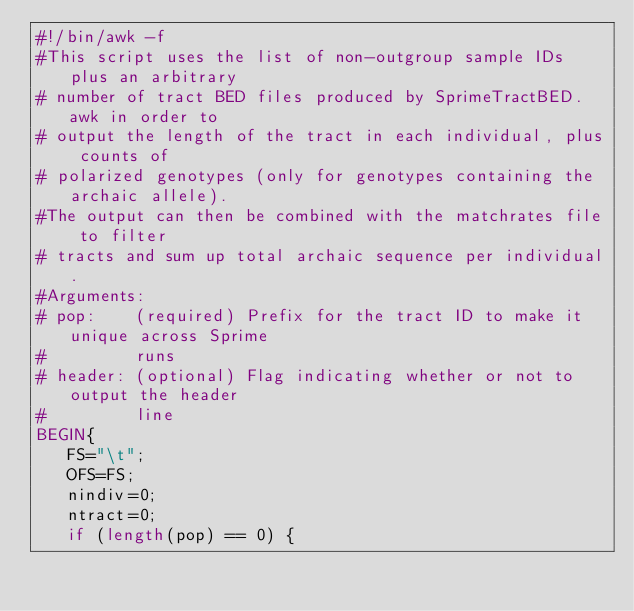<code> <loc_0><loc_0><loc_500><loc_500><_Awk_>#!/bin/awk -f
#This script uses the list of non-outgroup sample IDs plus an arbitrary
# number of tract BED files produced by SprimeTractBED.awk in order to
# output the length of the tract in each individual, plus counts of
# polarized genotypes (only for genotypes containing the archaic allele).
#The output can then be combined with the matchrates file to filter
# tracts and sum up total archaic sequence per individual.
#Arguments:
# pop:    (required) Prefix for the tract ID to make it unique across Sprime
#         runs
# header: (optional) Flag indicating whether or not to output the header
#         line
BEGIN{
   FS="\t";
   OFS=FS;
   nindiv=0;
   ntract=0;
   if (length(pop) == 0) {</code> 